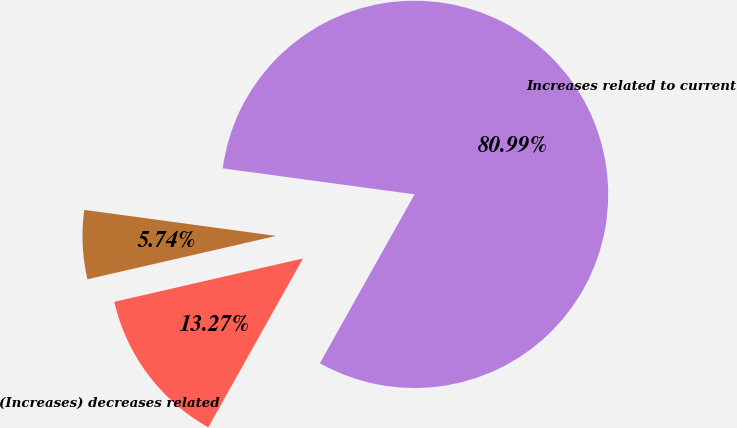<chart> <loc_0><loc_0><loc_500><loc_500><pie_chart><fcel>(Increases) decreases related<fcel>Increases related to current<fcel>Unnamed: 2<nl><fcel>13.27%<fcel>80.99%<fcel>5.74%<nl></chart> 